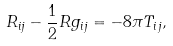<formula> <loc_0><loc_0><loc_500><loc_500>R _ { i j } - \frac { 1 } { 2 } R g _ { i j } = - 8 \pi T _ { i j } ,</formula> 